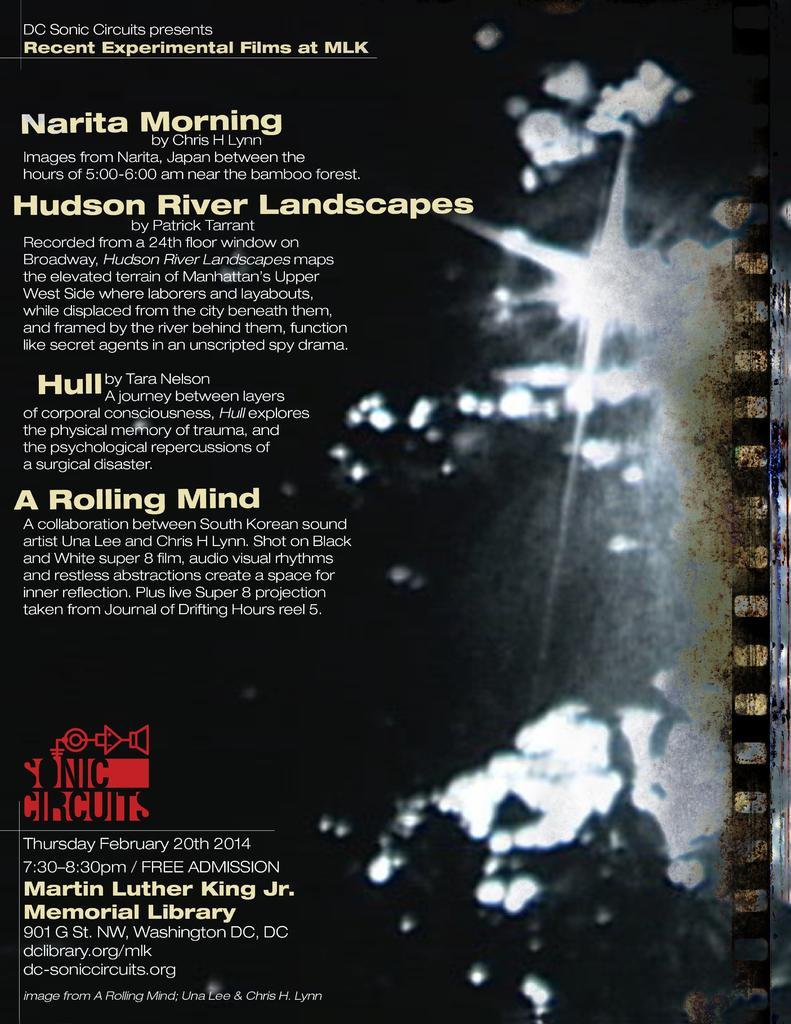Please provide a concise description of this image. In the foreground of this image, on the left, there is some text. 